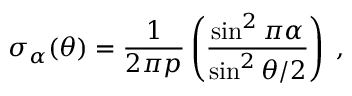Convert formula to latex. <formula><loc_0><loc_0><loc_500><loc_500>\sigma _ { \alpha } ( \theta ) = { \frac { 1 } { 2 \pi p } } \left ( { \frac { \sin ^ { 2 } { \pi \alpha } } { \sin ^ { 2 } { \theta / 2 } } } \right ) \, ,</formula> 